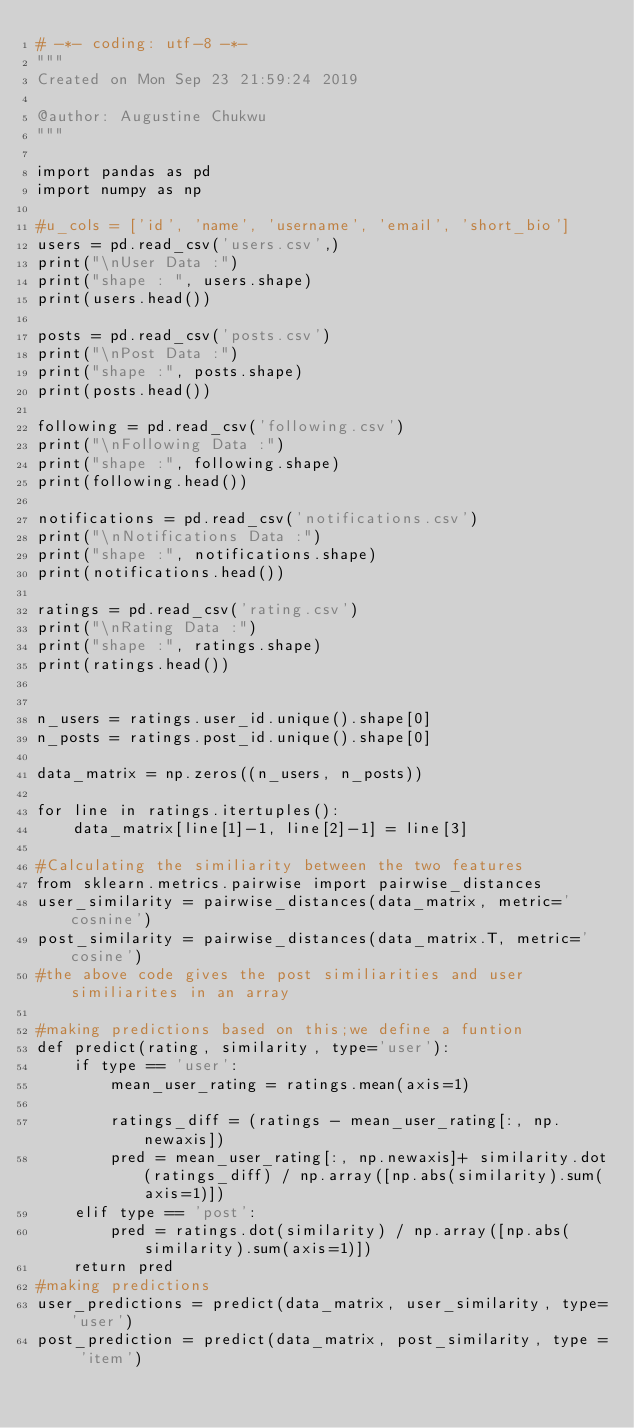<code> <loc_0><loc_0><loc_500><loc_500><_Python_># -*- coding: utf-8 -*-
"""
Created on Mon Sep 23 21:59:24 2019

@author: Augustine Chukwu
"""

import pandas as pd
import numpy as np

#u_cols = ['id', 'name', 'username', 'email', 'short_bio']
users = pd.read_csv('users.csv',)
print("\nUser Data :")
print("shape : ", users.shape)
print(users.head())

posts = pd.read_csv('posts.csv')
print("\nPost Data :")
print("shape :", posts.shape)
print(posts.head())

following = pd.read_csv('following.csv')
print("\nFollowing Data :")
print("shape :", following.shape)
print(following.head())

notifications = pd.read_csv('notifications.csv')
print("\nNotifications Data :")
print("shape :", notifications.shape)
print(notifications.head())

ratings = pd.read_csv('rating.csv')
print("\nRating Data :")
print("shape :", ratings.shape)
print(ratings.head())


n_users = ratings.user_id.unique().shape[0]
n_posts = ratings.post_id.unique().shape[0]

data_matrix = np.zeros((n_users, n_posts))

for line in ratings.itertuples():
    data_matrix[line[1]-1, line[2]-1] = line[3]
    
#Calculating the similiarity between the two features
from sklearn.metrics.pairwise import pairwise_distances
user_similarity = pairwise_distances(data_matrix, metric='cosnine')
post_similarity = pairwise_distances(data_matrix.T, metric='cosine')
#the above code gives the post similiarities and user similiarites in an array

#making predictions based on this;we define a funtion
def predict(rating, similarity, type='user'):
    if type == 'user':
        mean_user_rating = ratings.mean(axis=1)
        
        ratings_diff = (ratings - mean_user_rating[:, np.newaxis])
        pred = mean_user_rating[:, np.newaxis]+ similarity.dot(ratings_diff) / np.array([np.abs(similarity).sum(axis=1)])
    elif type == 'post':
        pred = ratings.dot(similarity) / np.array([np.abs(similarity).sum(axis=1)])
    return pred
#making predictions
user_predictions = predict(data_matrix, user_similarity, type='user')
post_prediction = predict(data_matrix, post_similarity, type = 'item')

    </code> 